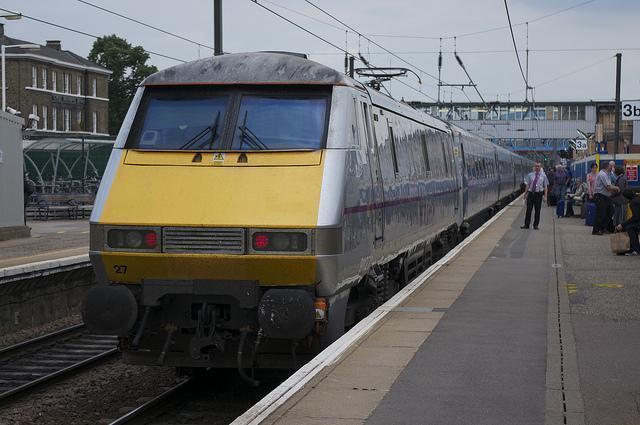How many books on the hand are there?
Give a very brief answer. 0. 